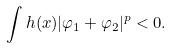<formula> <loc_0><loc_0><loc_500><loc_500>\int h ( x ) | \varphi _ { 1 } + \varphi _ { 2 } | ^ { p } < 0 .</formula> 